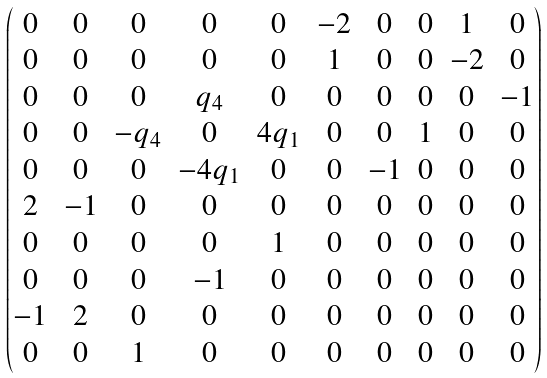Convert formula to latex. <formula><loc_0><loc_0><loc_500><loc_500>\begin{pmatrix} 0 & 0 & 0 & 0 & 0 & - 2 & 0 & 0 & 1 & 0 \\ 0 & 0 & 0 & 0 & 0 & 1 & 0 & 0 & - 2 & 0 \\ 0 & 0 & 0 & q _ { 4 } & 0 & 0 & 0 & 0 & 0 & - 1 \\ 0 & 0 & - q _ { 4 } & 0 & 4 q _ { 1 } & 0 & 0 & 1 & 0 & 0 \\ 0 & 0 & 0 & - 4 q _ { 1 } & 0 & 0 & - 1 & 0 & 0 & 0 \\ 2 & - 1 & 0 & 0 & 0 & 0 & 0 & 0 & 0 & 0 \\ 0 & 0 & 0 & 0 & 1 & 0 & 0 & 0 & 0 & 0 \\ 0 & 0 & 0 & - 1 & 0 & 0 & 0 & 0 & 0 & 0 \\ - 1 & 2 & 0 & 0 & 0 & 0 & 0 & 0 & 0 & 0 \\ 0 & 0 & 1 & 0 & 0 & 0 & 0 & 0 & 0 & 0 \end{pmatrix}</formula> 